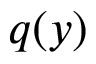<formula> <loc_0><loc_0><loc_500><loc_500>q ( y )</formula> 